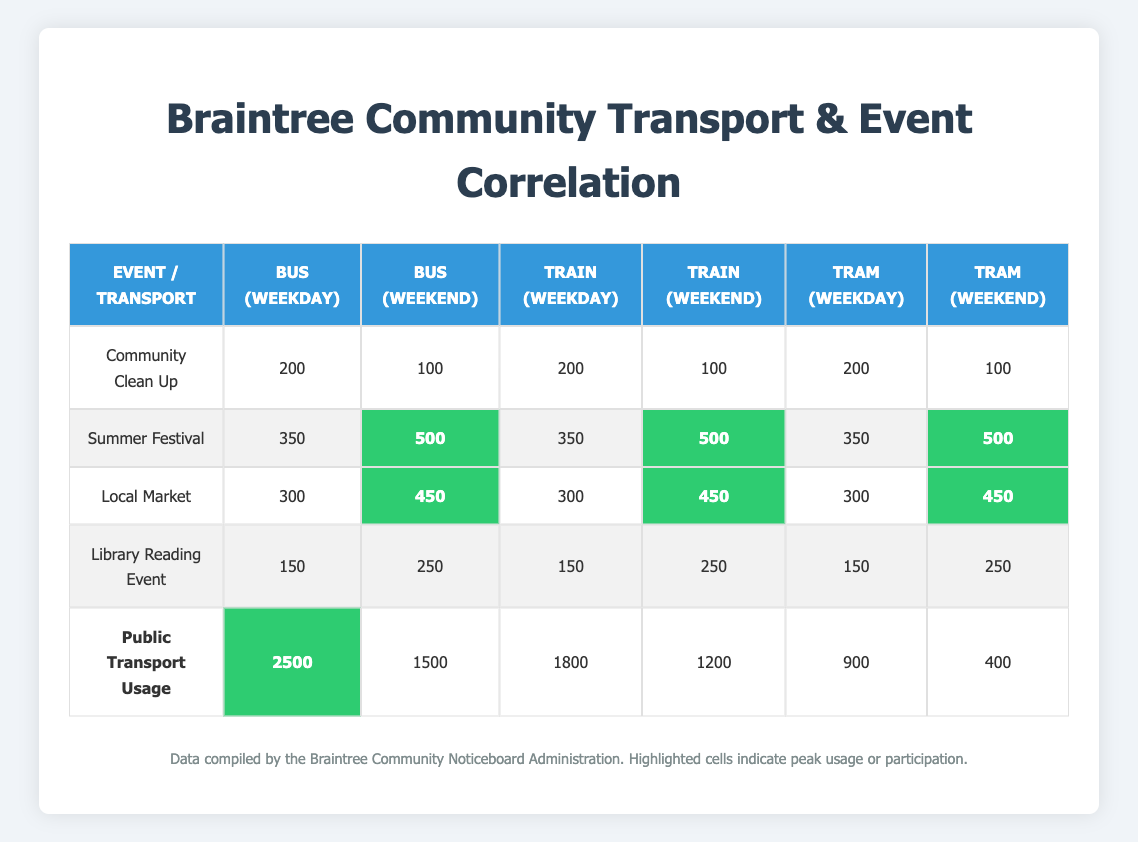What is the participation rate for the Summer Festival on the weekend? According to the table, the participation rate for the Summer Festival on the weekend is marked in the highlighted cell, which states its value as 500.
Answer: 500 How many people participated in the Community Clean Up on weekdays? The table shows that the participation for the Community Clean Up on weekdays is 200.
Answer: 200 Is the participation in the Library Reading Event higher on weekends than on weekdays? The table indicates that the participation on weekends is 250, while on weekdays it is only 150. Therefore, participation is higher on weekends.
Answer: Yes What is the total public transport usage for buses on weekdays? The total public transport usage for buses on weekdays is 2500 as shown in the corresponding cell for Bus (Weekday).
Answer: 2500 Which community event had the highest participation on weekends? By comparing the weekend participation rates, the Summer Festival, Local Market, and Library Reading Event have 500, 450, and 250 participants respectively, with the Summer Festival having the highest at 500.
Answer: Summer Festival What is the difference in public transport usage for trains between weekdays and weekends? The weekday usage for trains is 1800, while for weekends it is 1200. To find the difference, subtract the weekend value from the weekday value: 1800 - 1200 = 600.
Answer: 600 What is the average community event participation for weekdays? The events and their weekday participation rates are: Community Clean Up (200), Summer Festival (350), Local Market (300), and Library Reading Event (150). The total is 200 + 350 + 300 + 150 = 1000, and there are 4 events, so the average is 1000 / 4 = 250.
Answer: 250 Did more people use transport on weekdays compared to weekends? By examining the totals for both weekdays and weekends, weekday totals are 2500 (Bus) + 1800 (Train) + 900 (Tram) = 5200, and weekend totals are 1500 (Bus) + 1200 (Train) + 400 (Tram) = 3100. Since 5200 is greater than 3100, more people used transport on weekdays.
Answer: Yes What is the total participation for the Local Market on weekends? The table shows that the Local Market had a participation rate of 450 on weekends, which is noted in the corresponding cell.
Answer: 450 